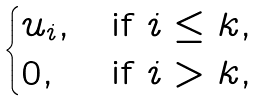Convert formula to latex. <formula><loc_0><loc_0><loc_500><loc_500>\begin{cases} u _ { i } , & \text {if } i \leq k , \\ 0 , & \text {if } i > k , \end{cases}</formula> 